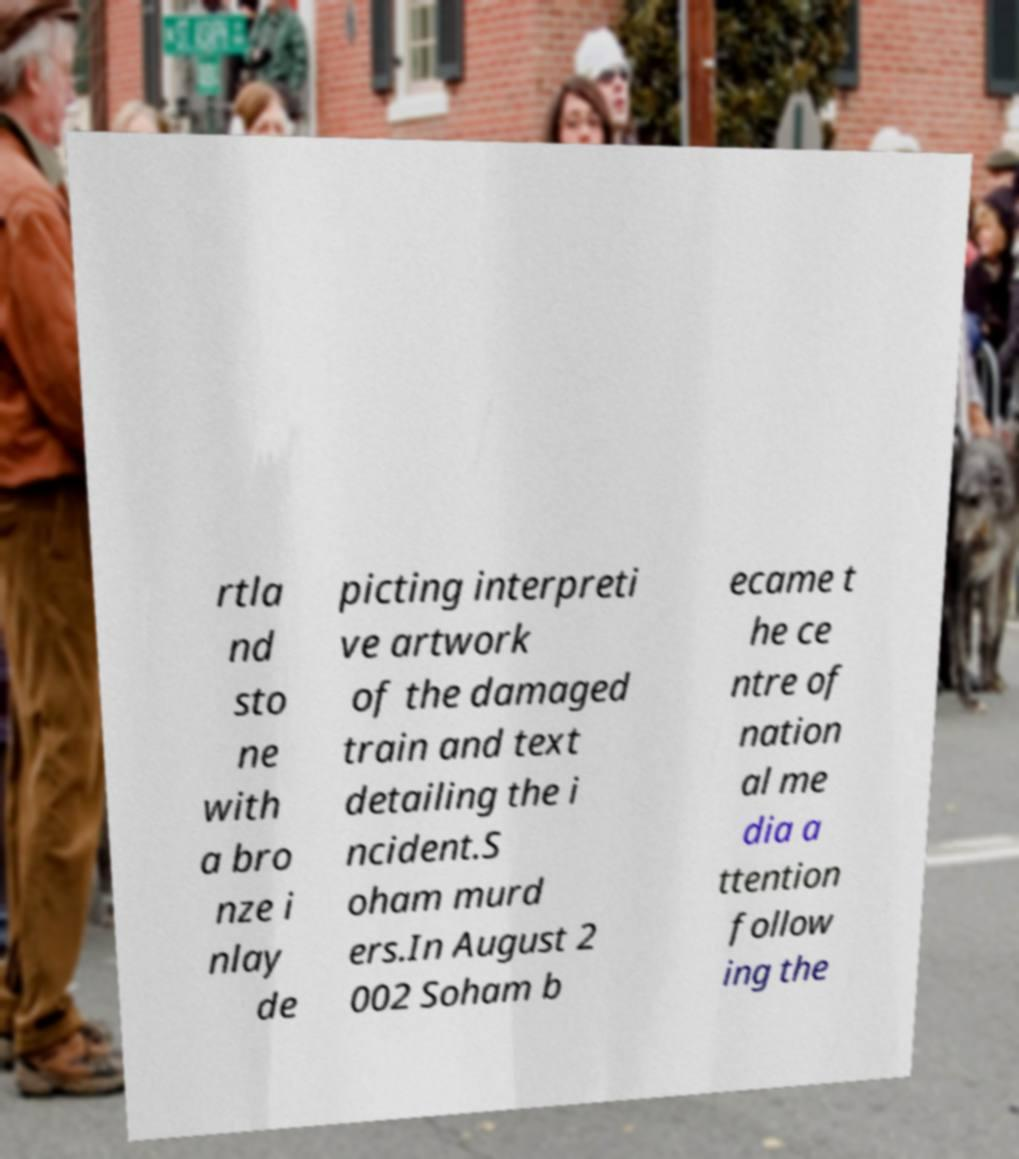Can you read and provide the text displayed in the image?This photo seems to have some interesting text. Can you extract and type it out for me? rtla nd sto ne with a bro nze i nlay de picting interpreti ve artwork of the damaged train and text detailing the i ncident.S oham murd ers.In August 2 002 Soham b ecame t he ce ntre of nation al me dia a ttention follow ing the 